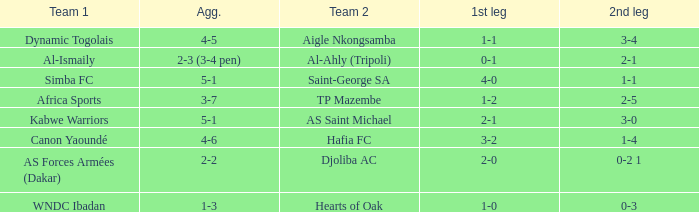Which group played opposite al-ismaily (team 1)? Al-Ahly (Tripoli). 